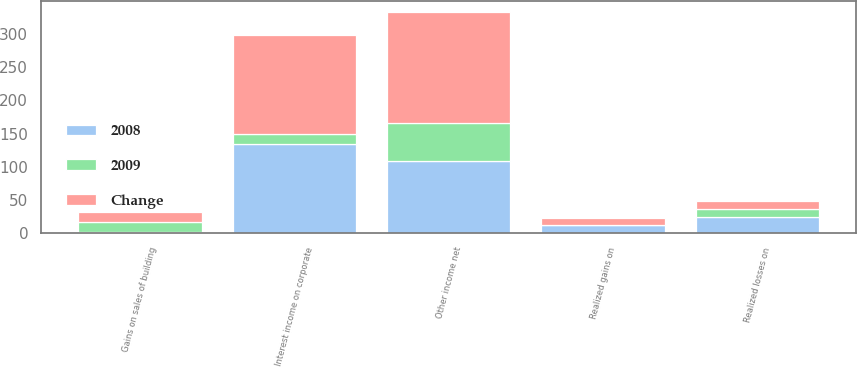<chart> <loc_0><loc_0><loc_500><loc_500><stacked_bar_chart><ecel><fcel>Interest income on corporate<fcel>Realized gains on<fcel>Realized losses on<fcel>Gains on sales of building<fcel>Other income net<nl><fcel>2008<fcel>134.2<fcel>11.4<fcel>23.8<fcel>2.2<fcel>108<nl><fcel>Change<fcel>149.5<fcel>10.1<fcel>11.4<fcel>16<fcel>166.5<nl><fcel>2009<fcel>15.3<fcel>1.3<fcel>12.4<fcel>13.8<fcel>58.5<nl></chart> 